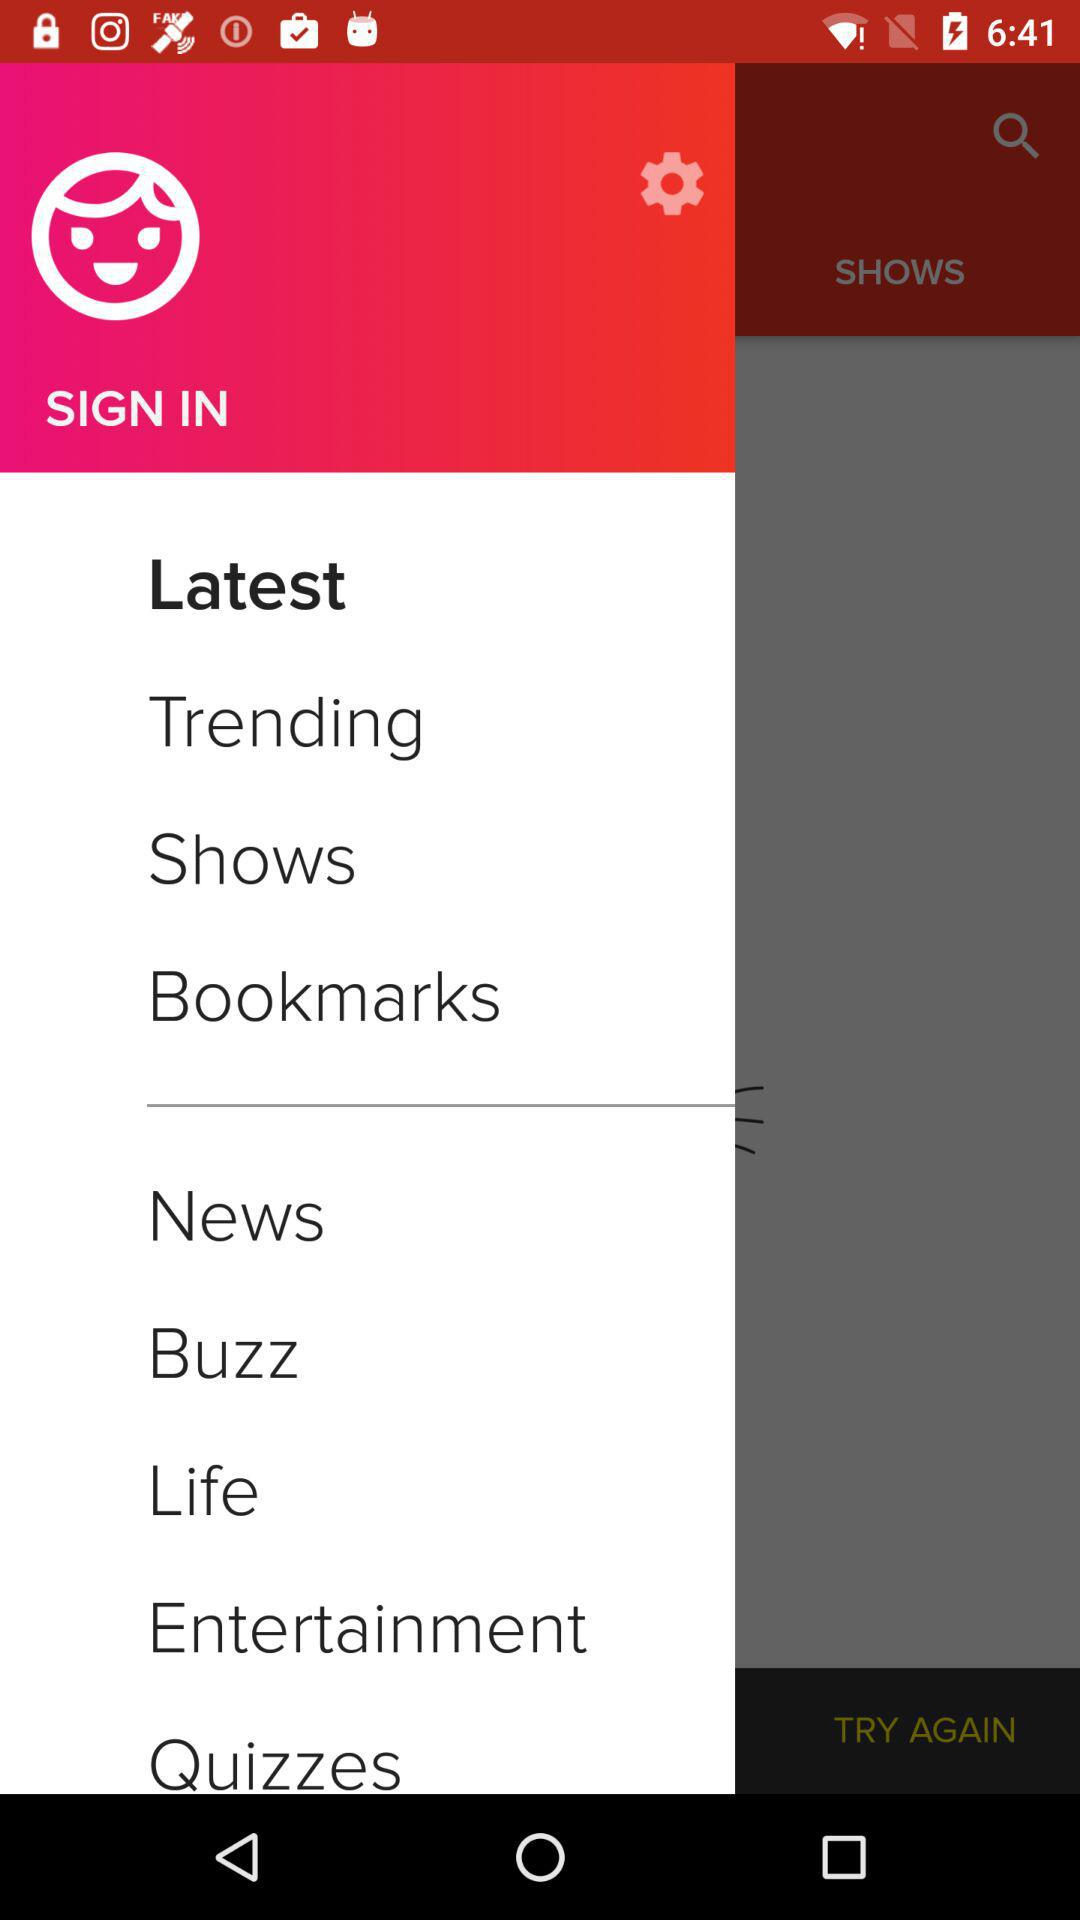What's the selected item? The selected item is "Latest". 